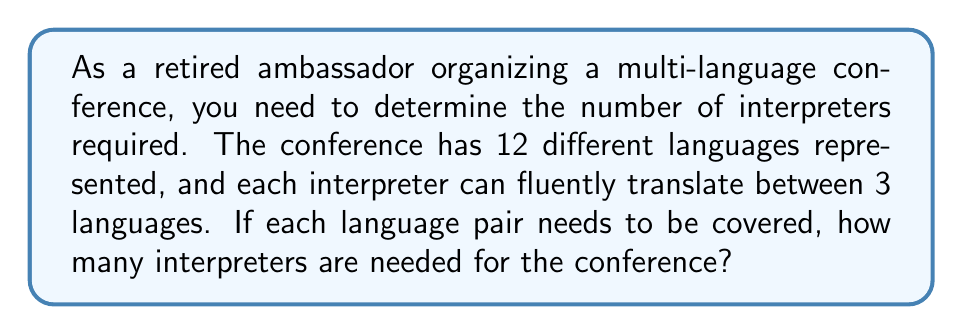Provide a solution to this math problem. Let's approach this step-by-step:

1) First, we need to calculate the total number of language pairs:
   $$\text{Number of language pairs} = \frac{n(n-1)}{2}$$
   Where $n$ is the number of languages.
   $$\text{Number of language pairs} = \frac{12(12-1)}{2} = \frac{12 \times 11}{2} = 66$$

2) Each interpreter can cover 3 languages, which means they can handle:
   $$\text{Pairs per interpreter} = \frac{3(3-1)}{2} = 3$$

3) To find the number of interpreters needed, we divide the total number of language pairs by the pairs each interpreter can handle:
   $$\text{Number of interpreters} = \frac{\text{Total language pairs}}{\text{Pairs per interpreter}}$$
   $$\text{Number of interpreters} = \frac{66}{3} = 22$$

Therefore, 22 interpreters are needed for the conference.
Answer: 22 interpreters 